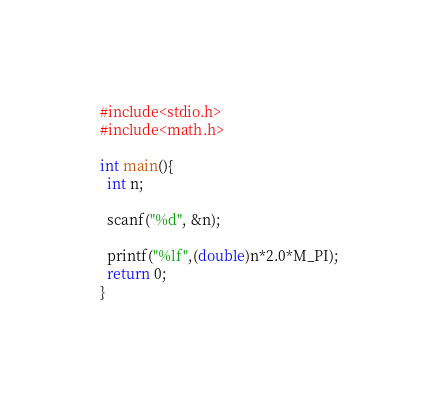Convert code to text. <code><loc_0><loc_0><loc_500><loc_500><_C_>#include<stdio.h>
#include<math.h>

int main(){
  int n;
  
  scanf("%d", &n);
  
  printf("%lf",(double)n*2.0*M_PI);
  return 0;
}</code> 